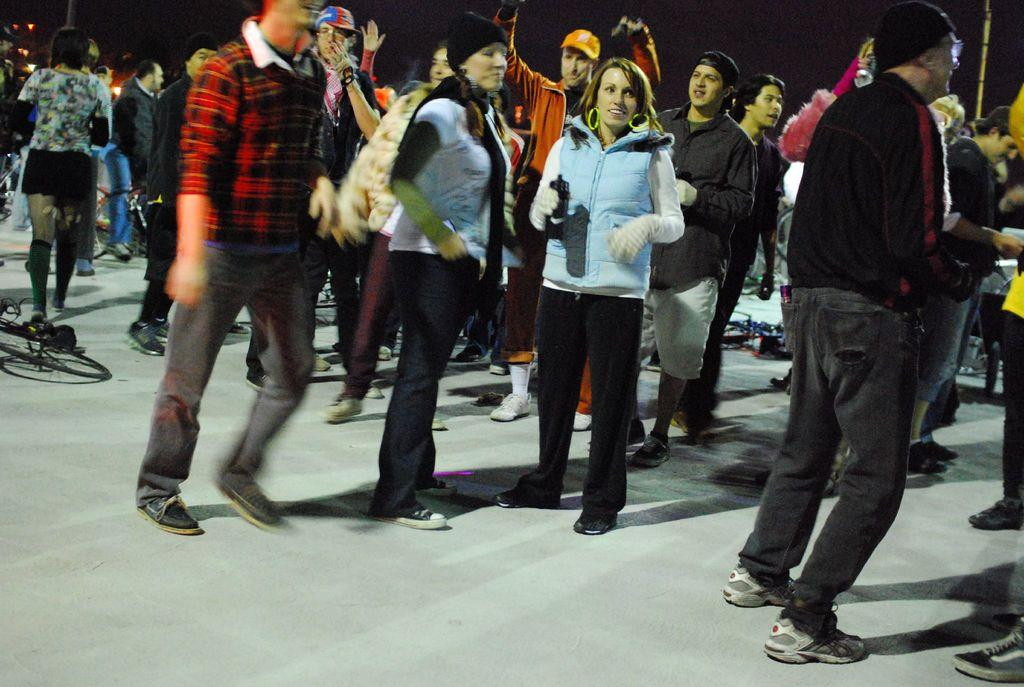How many people are in the image? There is a group of people in the image, but the exact number is not specified. What is the position of the people in the image? The people are standing on the floor in the image. What other objects are visible in the image? There are bicycles in the image. Where are the bicycles located in relation to the group of people? The bicycles are placed beside the group of people in the image. What type of mark can be seen on the bicycle's part in the image? There is no mention of a mark or a specific part of the bicycle in the provided facts, so it cannot be determined from the image. 